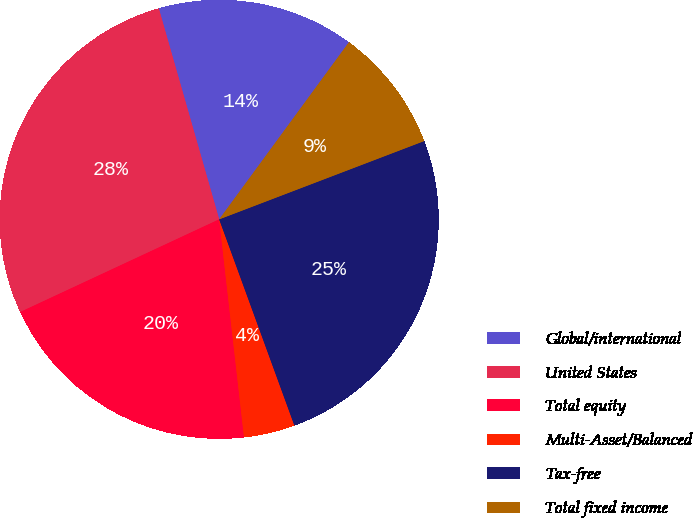<chart> <loc_0><loc_0><loc_500><loc_500><pie_chart><fcel>Global/international<fcel>United States<fcel>Total equity<fcel>Multi-Asset/Balanced<fcel>Tax-free<fcel>Total fixed income<nl><fcel>14.5%<fcel>27.5%<fcel>19.87%<fcel>3.76%<fcel>25.24%<fcel>9.13%<nl></chart> 